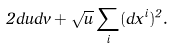Convert formula to latex. <formula><loc_0><loc_0><loc_500><loc_500>2 d u d v + \sqrt { u } \sum _ { i } ( d x ^ { i } ) ^ { 2 } .</formula> 